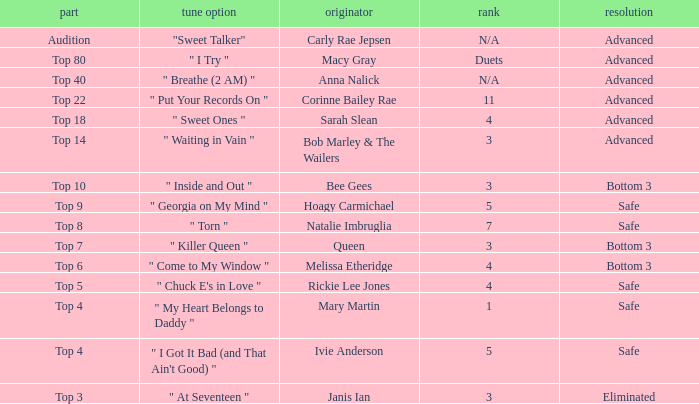What was the result of the Top 3 episode? Eliminated. 